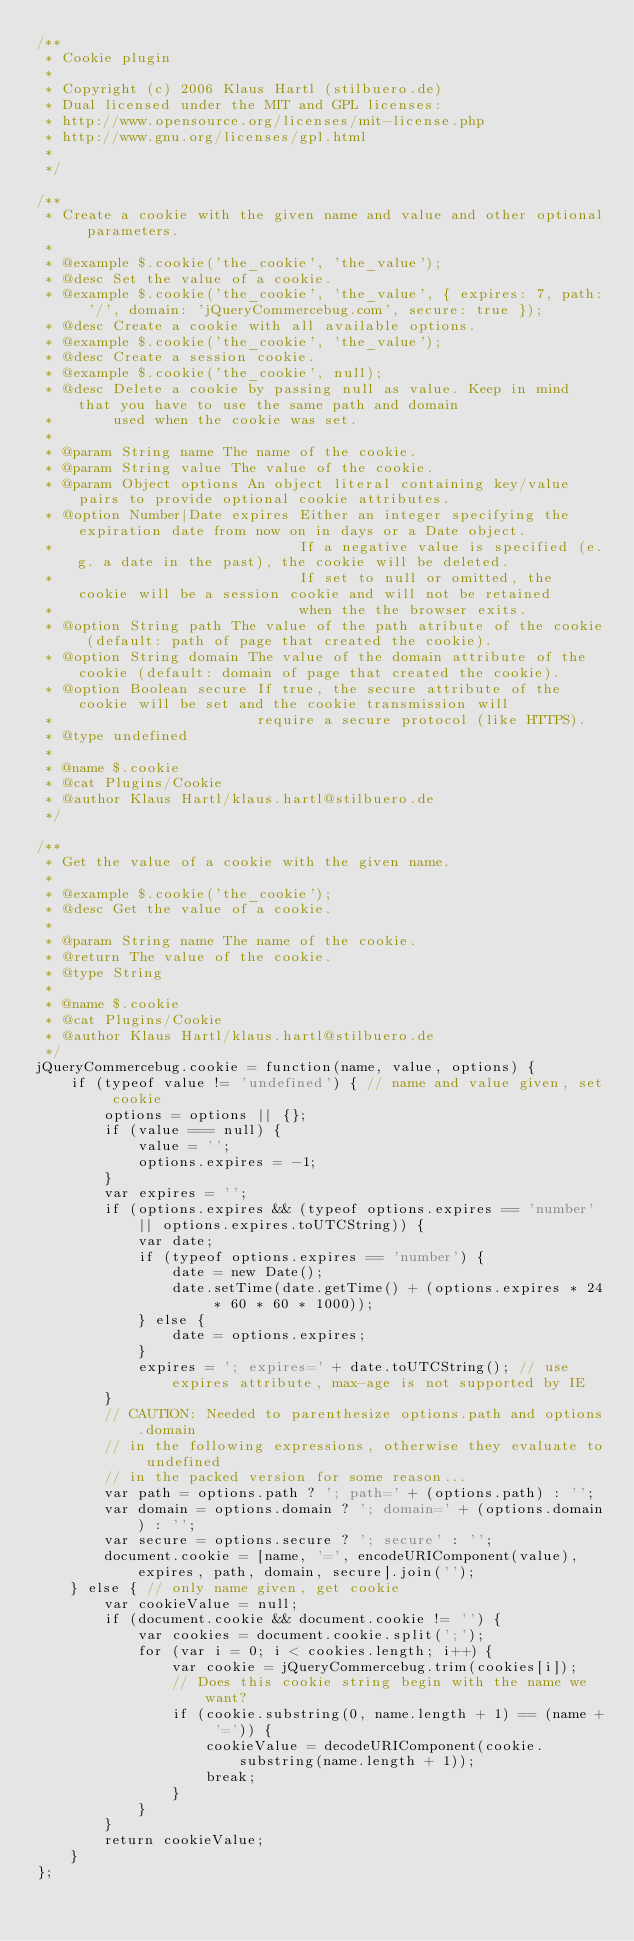Convert code to text. <code><loc_0><loc_0><loc_500><loc_500><_JavaScript_>/**
 * Cookie plugin
 *
 * Copyright (c) 2006 Klaus Hartl (stilbuero.de)
 * Dual licensed under the MIT and GPL licenses:
 * http://www.opensource.org/licenses/mit-license.php
 * http://www.gnu.org/licenses/gpl.html
 *
 */

/**
 * Create a cookie with the given name and value and other optional parameters.
 *
 * @example $.cookie('the_cookie', 'the_value');
 * @desc Set the value of a cookie.
 * @example $.cookie('the_cookie', 'the_value', { expires: 7, path: '/', domain: 'jQueryCommercebug.com', secure: true });
 * @desc Create a cookie with all available options.
 * @example $.cookie('the_cookie', 'the_value');
 * @desc Create a session cookie.
 * @example $.cookie('the_cookie', null);
 * @desc Delete a cookie by passing null as value. Keep in mind that you have to use the same path and domain
 *       used when the cookie was set.
 *
 * @param String name The name of the cookie.
 * @param String value The value of the cookie.
 * @param Object options An object literal containing key/value pairs to provide optional cookie attributes.
 * @option Number|Date expires Either an integer specifying the expiration date from now on in days or a Date object.
 *                             If a negative value is specified (e.g. a date in the past), the cookie will be deleted.
 *                             If set to null or omitted, the cookie will be a session cookie and will not be retained
 *                             when the the browser exits.
 * @option String path The value of the path atribute of the cookie (default: path of page that created the cookie).
 * @option String domain The value of the domain attribute of the cookie (default: domain of page that created the cookie).
 * @option Boolean secure If true, the secure attribute of the cookie will be set and the cookie transmission will
 *                        require a secure protocol (like HTTPS).
 * @type undefined
 *
 * @name $.cookie
 * @cat Plugins/Cookie
 * @author Klaus Hartl/klaus.hartl@stilbuero.de
 */

/**
 * Get the value of a cookie with the given name.
 *
 * @example $.cookie('the_cookie');
 * @desc Get the value of a cookie.
 *
 * @param String name The name of the cookie.
 * @return The value of the cookie.
 * @type String
 *
 * @name $.cookie
 * @cat Plugins/Cookie
 * @author Klaus Hartl/klaus.hartl@stilbuero.de
 */
jQueryCommercebug.cookie = function(name, value, options) {
    if (typeof value != 'undefined') { // name and value given, set cookie
        options = options || {};
        if (value === null) {
            value = '';
            options.expires = -1;
        }
        var expires = '';
        if (options.expires && (typeof options.expires == 'number' || options.expires.toUTCString)) {
            var date;
            if (typeof options.expires == 'number') {
                date = new Date();
                date.setTime(date.getTime() + (options.expires * 24 * 60 * 60 * 1000));
            } else {
                date = options.expires;
            }
            expires = '; expires=' + date.toUTCString(); // use expires attribute, max-age is not supported by IE
        }
        // CAUTION: Needed to parenthesize options.path and options.domain
        // in the following expressions, otherwise they evaluate to undefined
        // in the packed version for some reason...
        var path = options.path ? '; path=' + (options.path) : '';
        var domain = options.domain ? '; domain=' + (options.domain) : '';
        var secure = options.secure ? '; secure' : '';
        document.cookie = [name, '=', encodeURIComponent(value), expires, path, domain, secure].join('');
    } else { // only name given, get cookie
        var cookieValue = null;
        if (document.cookie && document.cookie != '') {
            var cookies = document.cookie.split(';');
            for (var i = 0; i < cookies.length; i++) {
                var cookie = jQueryCommercebug.trim(cookies[i]);
                // Does this cookie string begin with the name we want?
                if (cookie.substring(0, name.length + 1) == (name + '=')) {
                    cookieValue = decodeURIComponent(cookie.substring(name.length + 1));
                    break;
                }
            }
        }
        return cookieValue;
    }
};</code> 